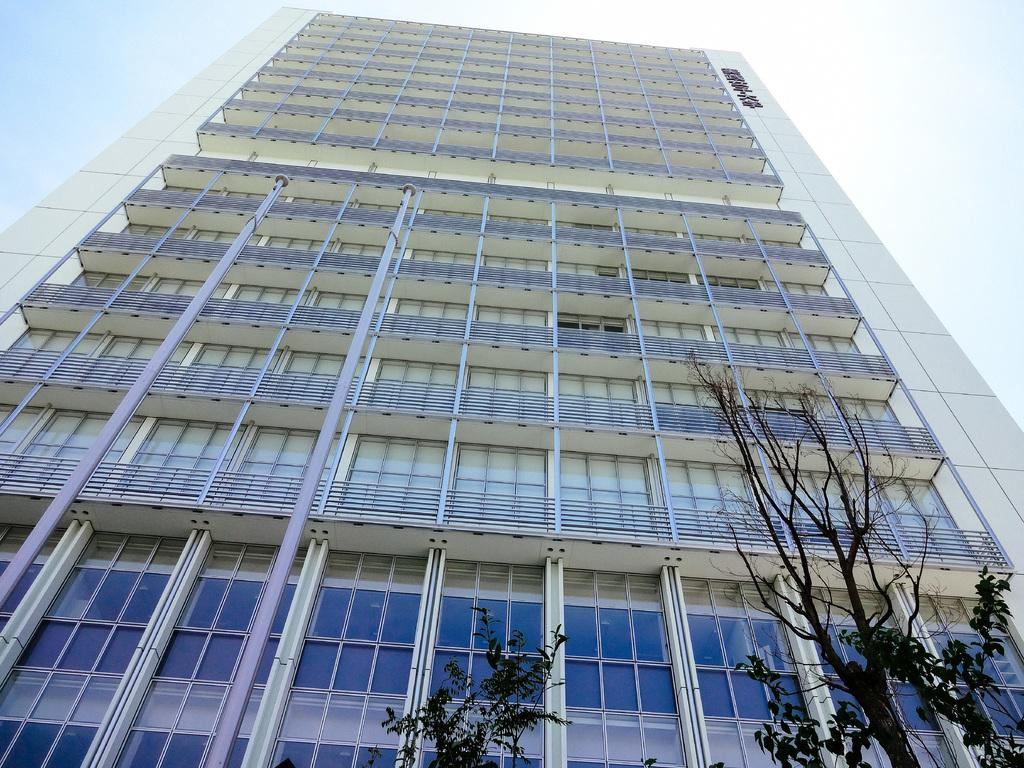What is the main structure in the center of the image? There is a building in the center of the image. What type of vegetation is present at the bottom of the image? There are trees at the bottom of the image. What is written or displayed on the building? There is text on the building. What can be seen above the building in the image? The sky is visible at the top of the image. How many strands of hair can be seen on the building in the image? There are no strands of hair present on the building in the image. What type of furniture is visible in the bedroom in the image? There is no bedroom present in the image; it features a building, trees, text, and the sky. 